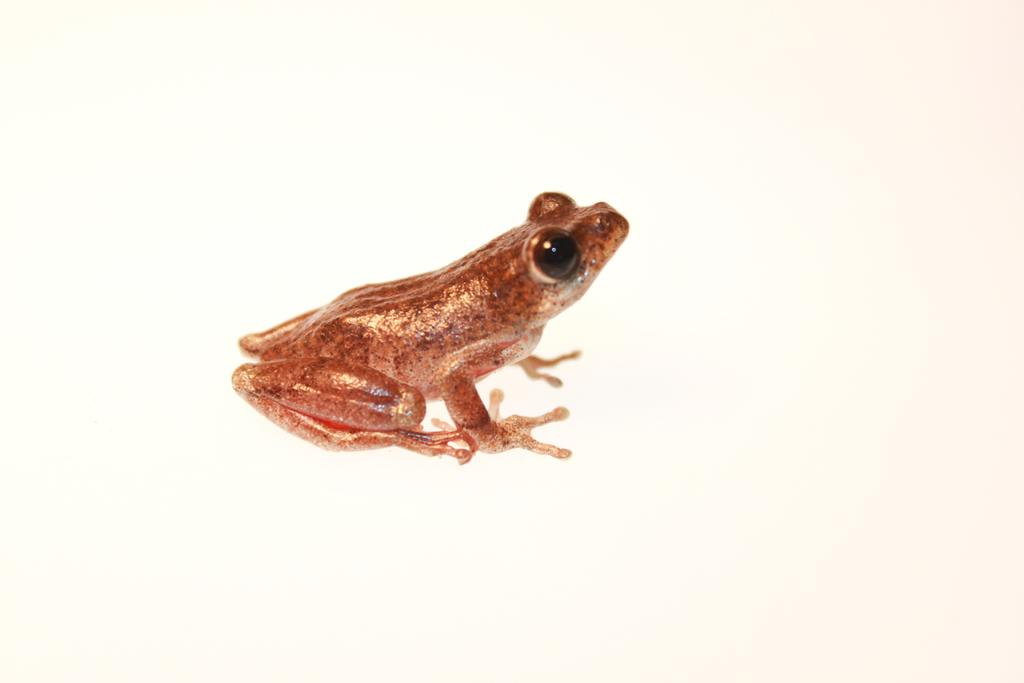What is the main subject in the center of the image? There is a frog in the center of the image. What is the color of the frog? The frog is brown in color. What type of sink can be seen in the background of the image? There is no sink present in the image; it features a frog in the center. What type of clouds are visible above the frog in the image? There are no clouds visible in the image; it only features a brown frog in the center. 